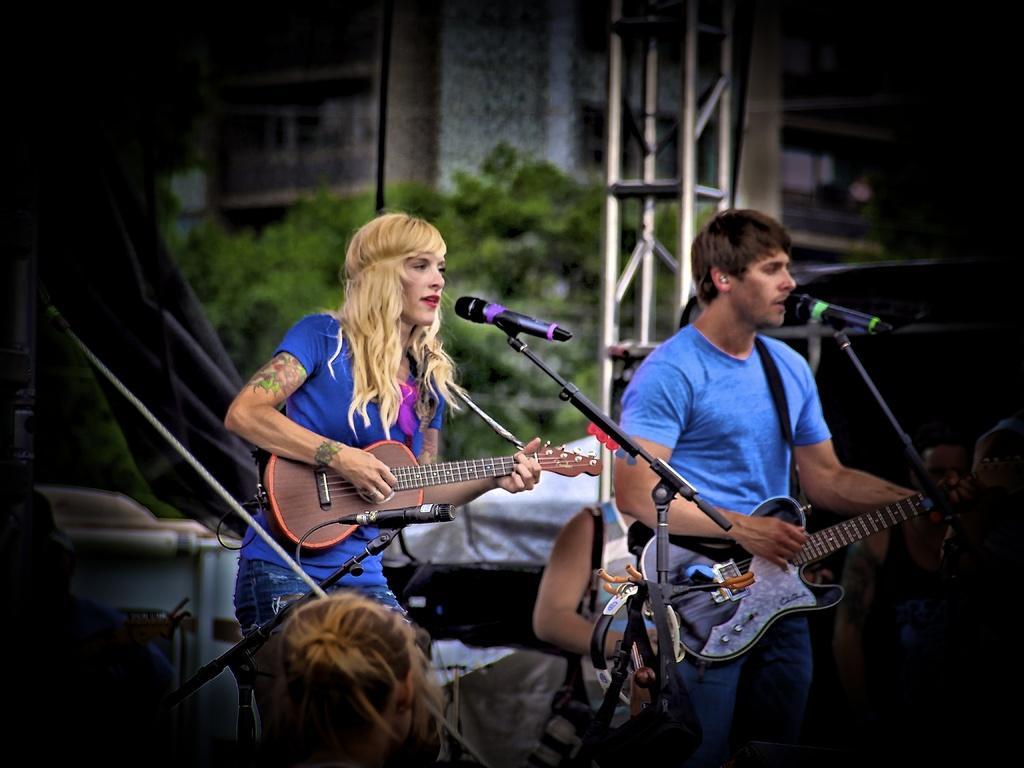In one or two sentences, can you explain what this image depicts? In this image I can see few people are standing and holding guitars, I can also see few mics in front of them. In the background I can see a tree and a building. 